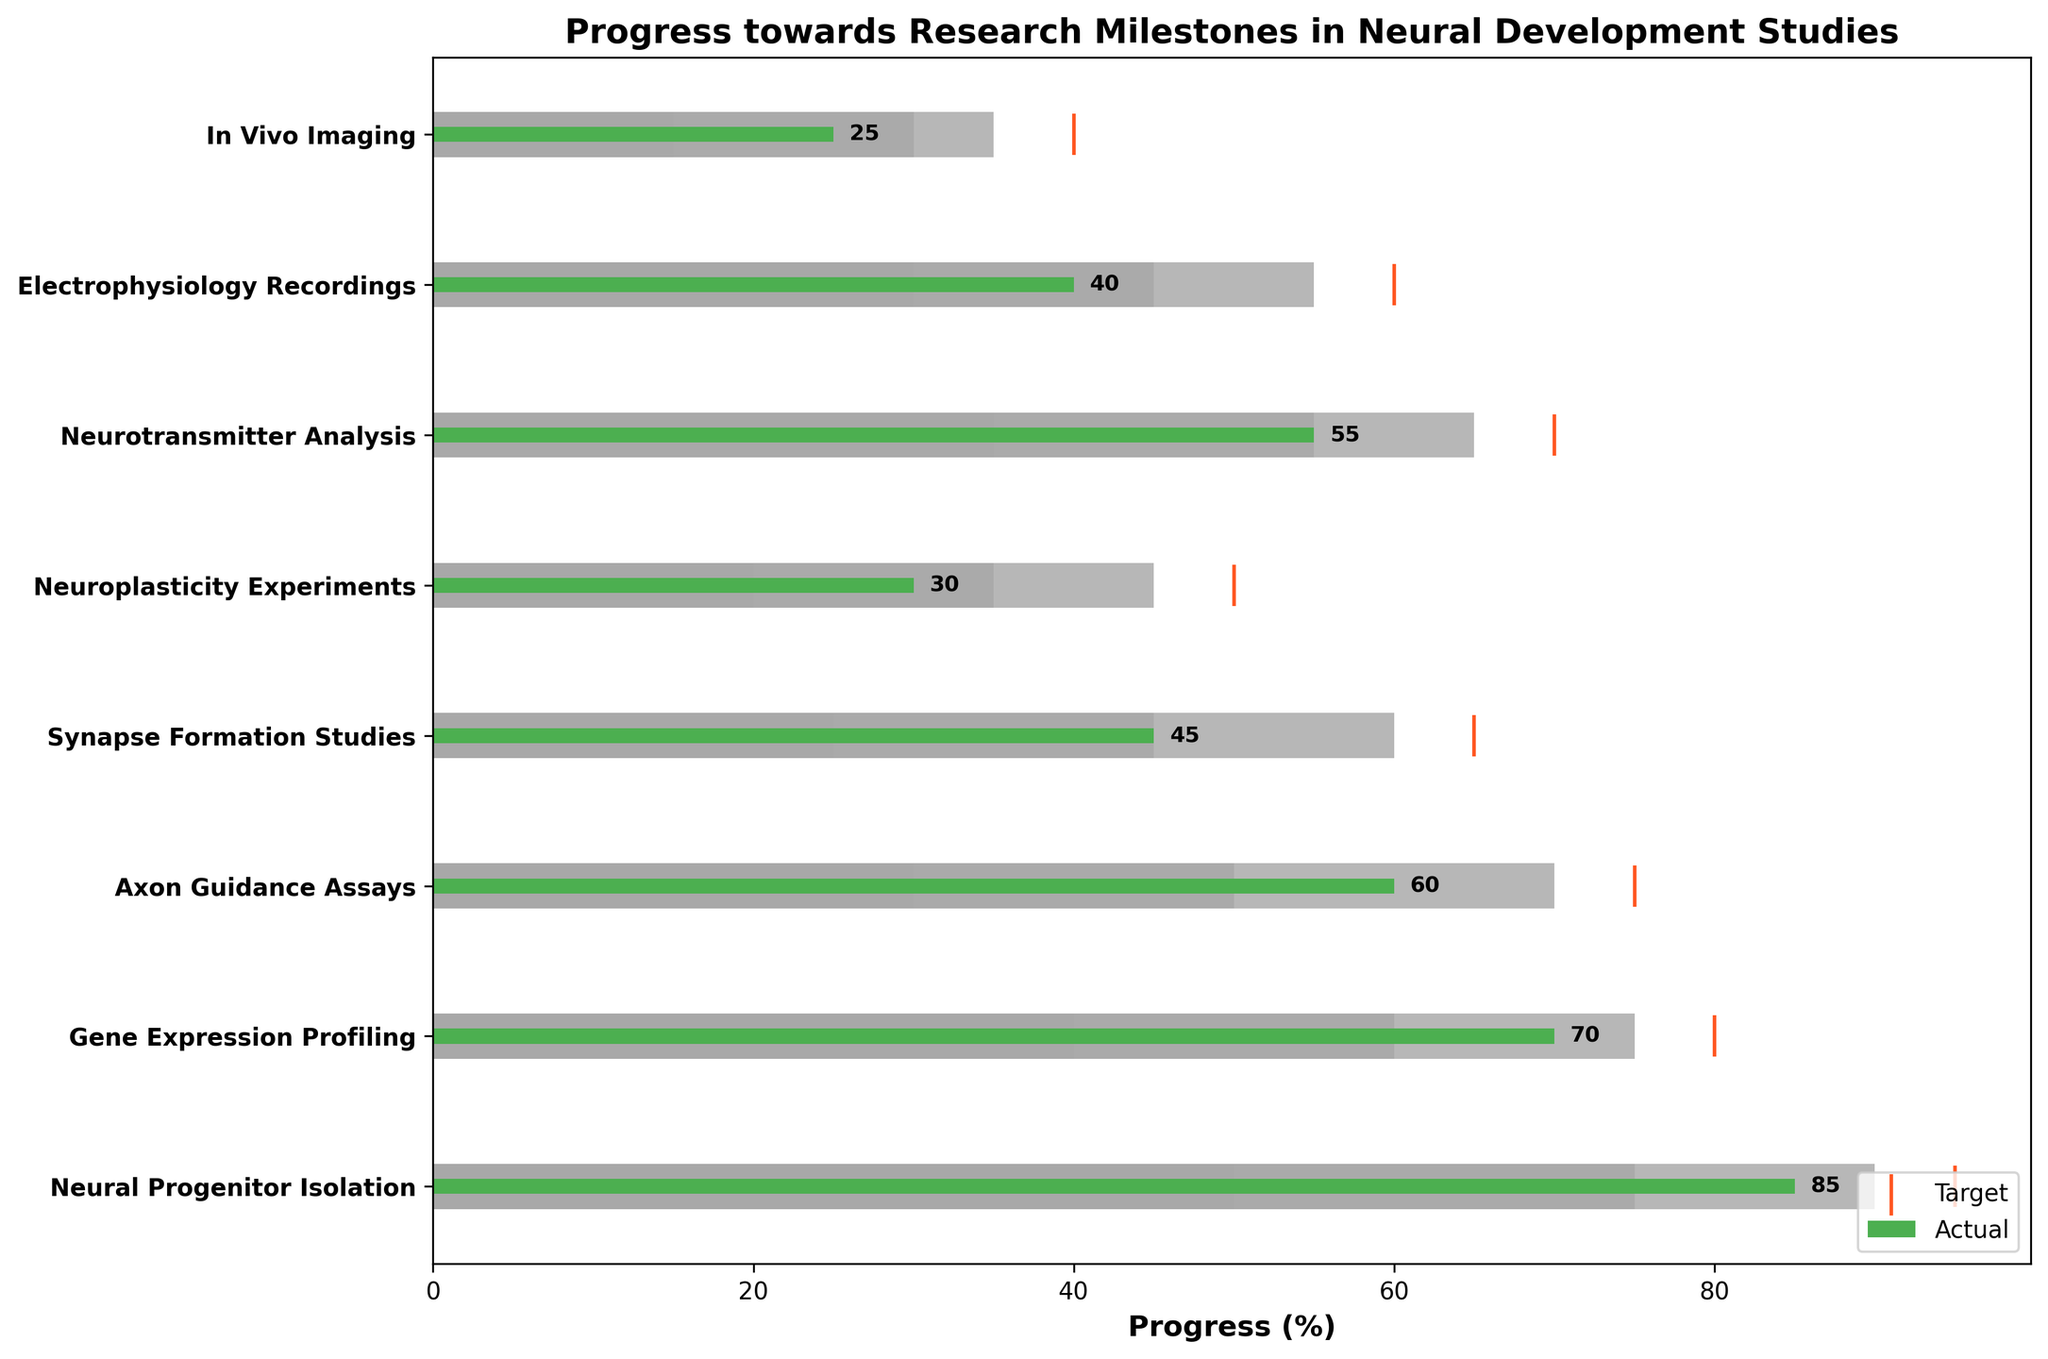What's the total number of experimental stages displayed in the chart? Count the total number of categories listed on the y-axis.
Answer: 8 What is the title of the chart? Read the title displayed at the top of the chart.
Answer: Progress towards Research Milestones in Neural Development Studies Which experimental stage shows the highest progress in actual values? Compare the actual values for all experimental stages; find the stage with the highest actual value. Neural Progenitor Isolation has the highest actual value of 85.
Answer: Neural Progenitor Isolation By how much does the actual value of Gene Expression Profiling fall short of its target? Subtract the actual value of Gene Expression Profiling (70) from its target value (80). 80 - 70 = 10.
Answer: 10 Which experimental stage has an actual progress value that reached its third range (90-100% complete)? Find the stages where the actual value is in the third range. Neural Progenitor Isolation (Actual is 85, within Range3 which is 90).
Answer: Neural Progenitor Isolation What's the average actual value across all experimental stages? Sum all actual values and divide by the number of stages: (85 + 70 + 60 + 45 + 30 + 55 + 40 + 25) / 8 = 51.25.
Answer: 51.25 Which experimental stage has the smallest gap between its actual value and its target value? Calculate the differences for each experimental stage and find the smallest: Neural Progenitor Isolation (95-85=10), Gene Expression Profiling (80-70=10), Axon Guidance Assays (75-60=15), Synapse Formation Studies (65-45=20), Neuroplasticity Experiments (50-30=20), Neurotransmitter Analysis (70-55=15), Electrophysiology Recordings (60-40=20), In Vivo Imaging (40-25=15). Both Neural Progenitor Isolation and Gene Expression Profiling have the smallest gap of 10.
Answer: Neural Progenitor Isolation and Gene Expression Profiling Which two experimental stages are closest to completing their target values? Identify the stages with actual values nearest to the target values: Neural Progenitor Isolation (85/95), Gene Expression Profiling (70/80). Both stages have a gap of 10 to their target.
Answer: Neural Progenitor Isolation and Gene Expression Profiling What's the median actual value of all experimental stages? List the actual values in order: 25, 30, 40, 45, 55, 60, 70, 85. The median is the middle value in an ordered list of numbers. If the list is even, the median is the average of the two middle numbers. In this case, (55+60)/2 = 57.5.
Answer: 57.5 What's the difference between the highest and the lowest actual values? Subtract the lowest actual value from the highest actual value: 85 - 25 = 60.
Answer: 60 